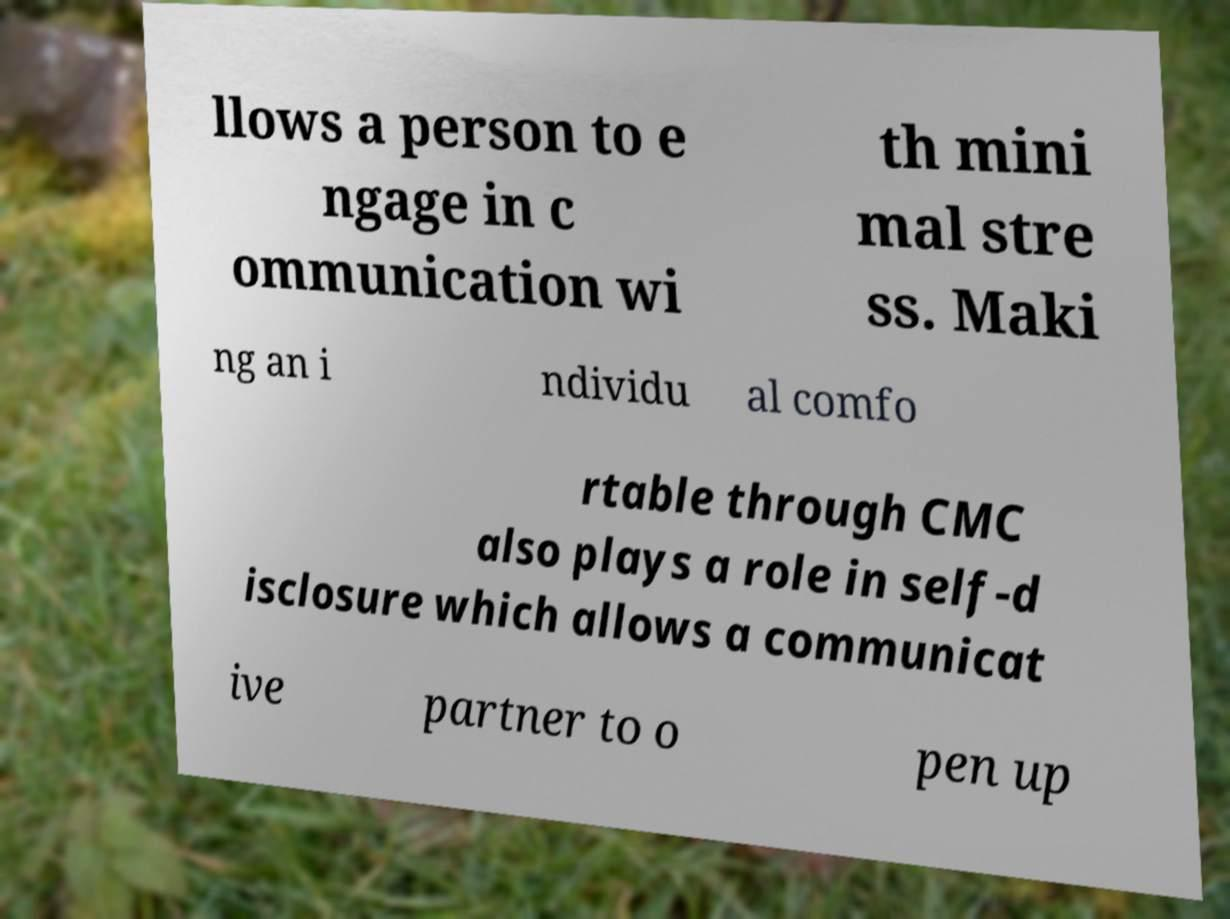Could you assist in decoding the text presented in this image and type it out clearly? llows a person to e ngage in c ommunication wi th mini mal stre ss. Maki ng an i ndividu al comfo rtable through CMC also plays a role in self-d isclosure which allows a communicat ive partner to o pen up 